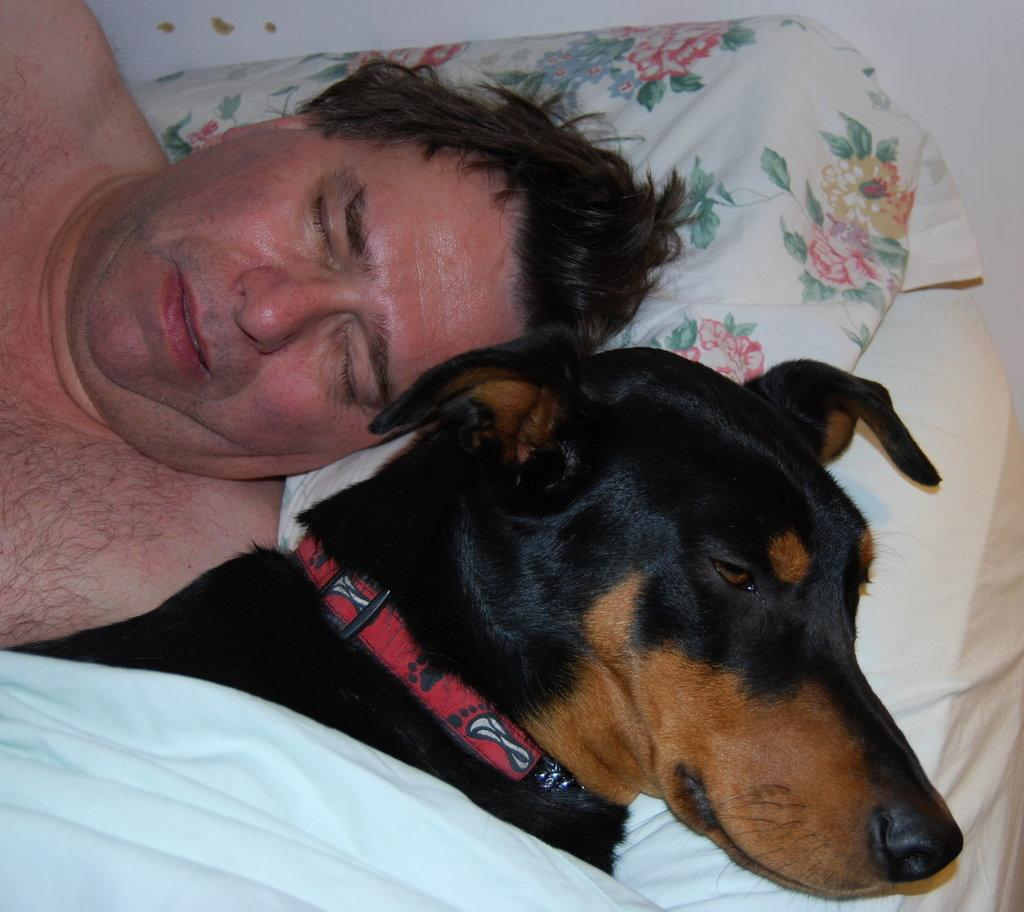What is the main subject of the image? There is a person laying on a bed in the image. What is the person doing in the image? The person is sleeping. Is there any other living creature in the image? Yes, there is a dog beside the person. What is the dog wearing in the image? The dog has a white cloth on it. What type of advice can be seen written on the person's skin in the image? There is no advice written on the person's skin in the image. Can you tell me how many people are walking on the street in the image? There is no street or people walking in the image; it features a person sleeping on a bed with a dog beside them. 